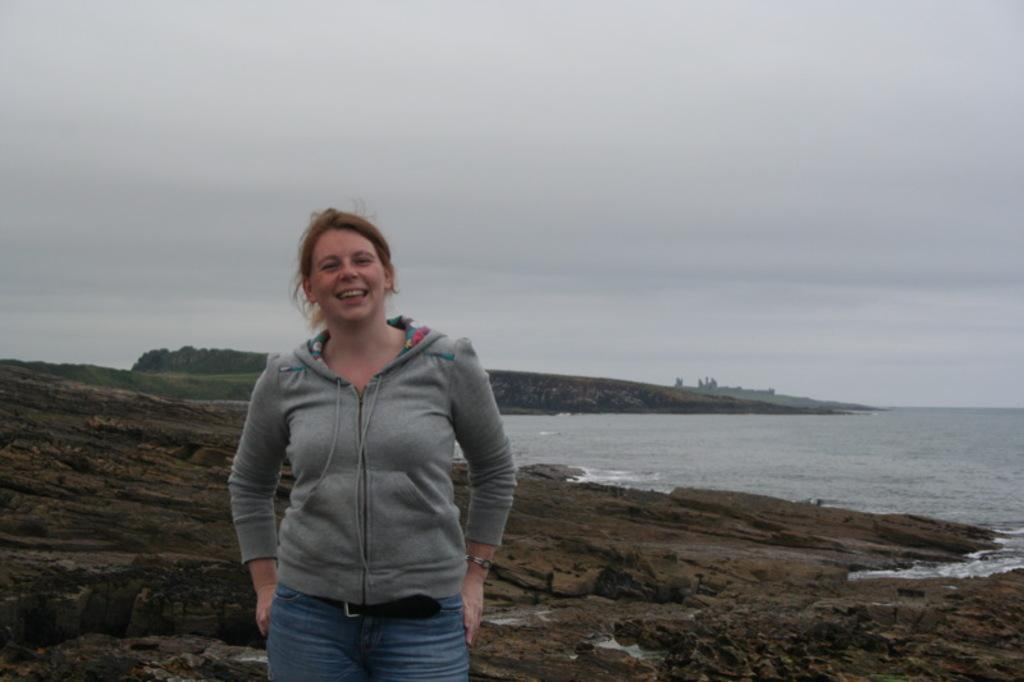What is the main subject of the image? There is a person standing in the image. What type of clothing is the person wearing? The person is wearing an ash coat and jeans. What can be seen in the background of the image? There are trees, water, and a rock visible in the background. How would you describe the color of the sky in the image? The sky is in white and blue color. What type of leaf is the person holding in the image? There is no leaf present in the image; the person is not holding anything. What type of cap is the person wearing in the image? The person is not wearing a cap in the image; they are wearing an ash coat. 